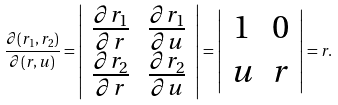Convert formula to latex. <formula><loc_0><loc_0><loc_500><loc_500>\frac { \partial ( r _ { 1 } , r _ { 2 } ) } { \partial ( r , u ) } = \left | \begin{array} { c c } \frac { \partial r _ { 1 } } { \partial r } & \frac { \partial r _ { 1 } } { \partial u } \\ \frac { \partial r _ { 2 } } { \partial r } & \frac { \partial r _ { 2 } } { \partial u } \\ \end{array} \right | = \left | \begin{array} { c c } 1 & 0 \\ u & r \\ \end{array} \right | = r .</formula> 